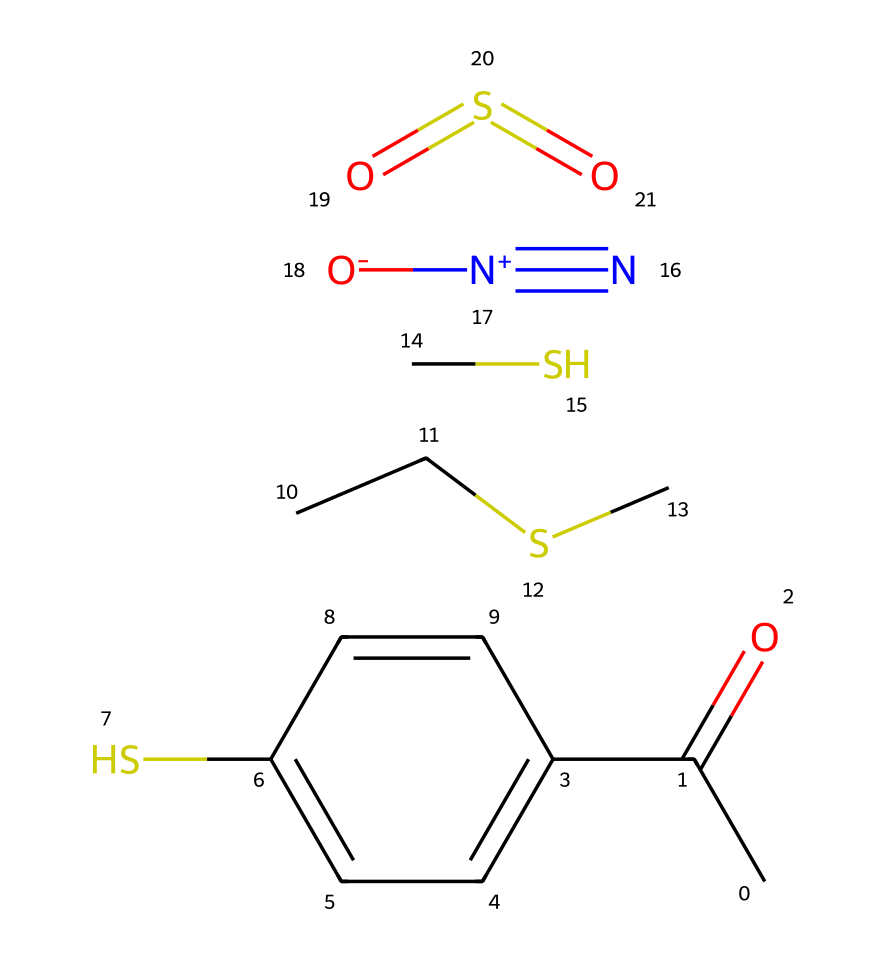What is the main functional group present in this compound? The compound contains a carbonyl group (C=O) indicated by the CC(=O) structure, which is characteristic of ketones or aldehydes.
Answer: carbonyl How many sulfur atoms are present in this chemical? By examining the SMILES notation, there are two sulfur atoms represented in the structure (one in the CCSC part and the other in the O=S=O part).
Answer: two What type of reaction could this chemical most likely participate in? Given the presence of the sulfur and nitrogen components, this chemical can participate in reduction reactions, which are often involved in transforming such compounds.
Answer: reduction What is the role of the nitrogen in this compound? The nitrogen is part of a nitro group (N#[N+][O-]), which typically indicates that this compound could contribute to a smoky aroma resembling gunpowder or explosives.
Answer: aromatic Which element in the chemical indicates the potential for a smoky scent? The presence of nitrogen (N) in the structure, along with sulfur and carbon, is indicative of the compounds associated with gunpowder smoke, enhancing the smoky aromatic profile.
Answer: nitrogen How many aromatic rings are present in this molecule? Looking closely at the structure reveals one aromatic ring, which is the phenyl ring attached to the carbonyl group, confirming its aromatic nature.
Answer: one 